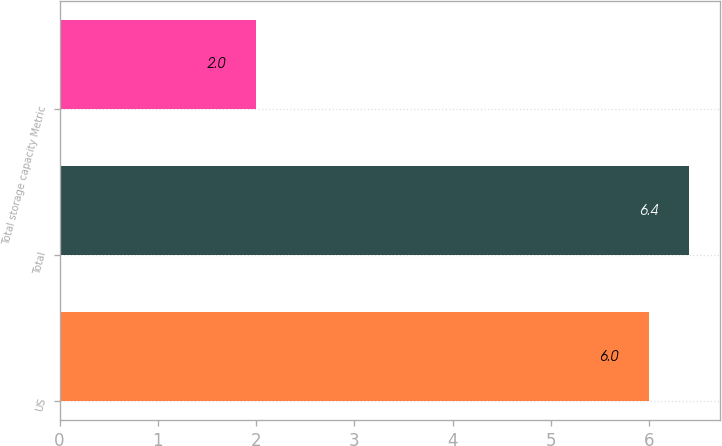<chart> <loc_0><loc_0><loc_500><loc_500><bar_chart><fcel>US<fcel>Total<fcel>Total storage capacity Metric<nl><fcel>6<fcel>6.4<fcel>2<nl></chart> 